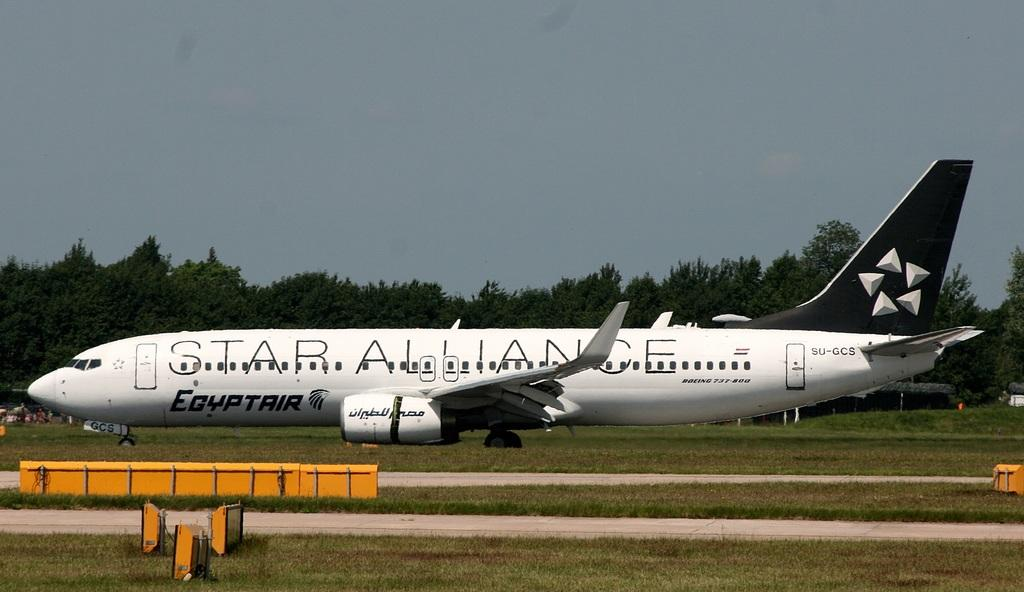<image>
Write a terse but informative summary of the picture. A white Star Alliance plane is parked outdoors in the grass. 